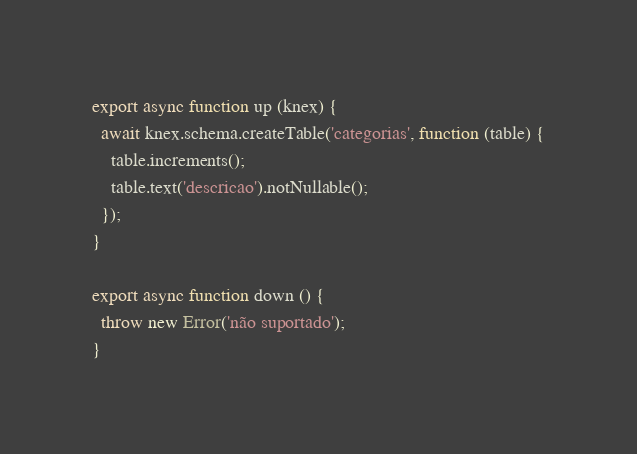Convert code to text. <code><loc_0><loc_0><loc_500><loc_500><_JavaScript_>
export async function up (knex) {
  await knex.schema.createTable('categorias', function (table) {
    table.increments();
    table.text('descricao').notNullable();
  });
}

export async function down () {
  throw new Error('não suportado');
}
</code> 